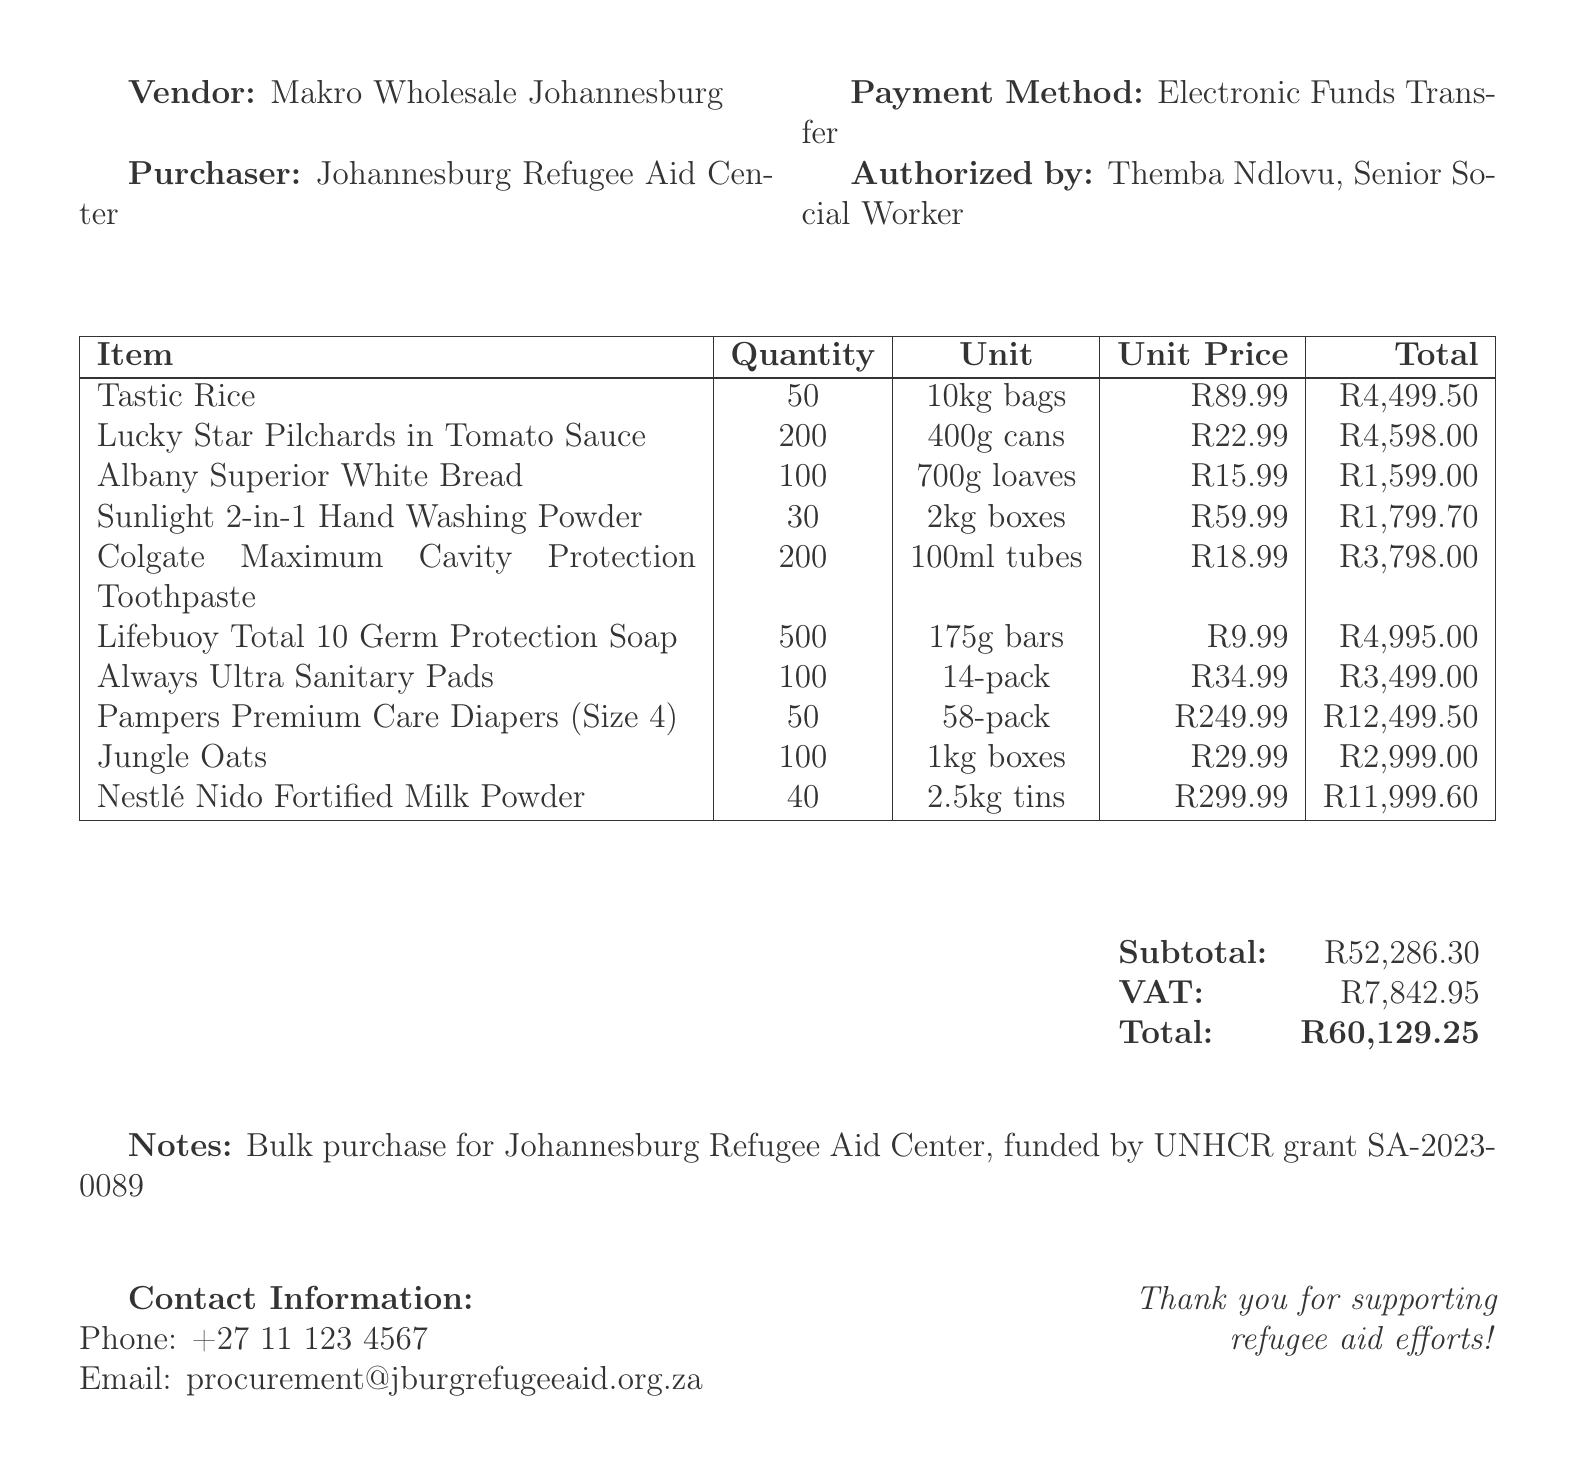What is the receipt number? The receipt number is explicitly stated near the top of the document.
Answer: REC-2023-05674 What is the total amount of the purchase? The total amount is summarized at the bottom of the document.
Answer: R60,129.25 Who is the vendor? The vendor is identified in the vendor section of the document.
Answer: Makro Wholesale Johannesburg When was the purchase made? The date of the transaction is clearly mentioned in the document.
Answer: 2023-06-15 How many cans of Lucky Star Pilchards were purchased? The quantity of Lucky Star Pilchards is listed within the items table.
Answer: 200 What does the purchase fund? The notes section indicates the purpose of the purchase.
Answer: Refugee shelter Who is authorized to make this purchase? The authorized person is mentioned towards the end of the document.
Answer: Themba Ndlovu, Senior Social Worker What payment method was used? The payment method is specified in the document under payment details.
Answer: Electronic Funds Transfer How many bars of Lifebuoy soap were included in the order? The quantity of Lifebuoy soap is detailed in the items section.
Answer: 500 